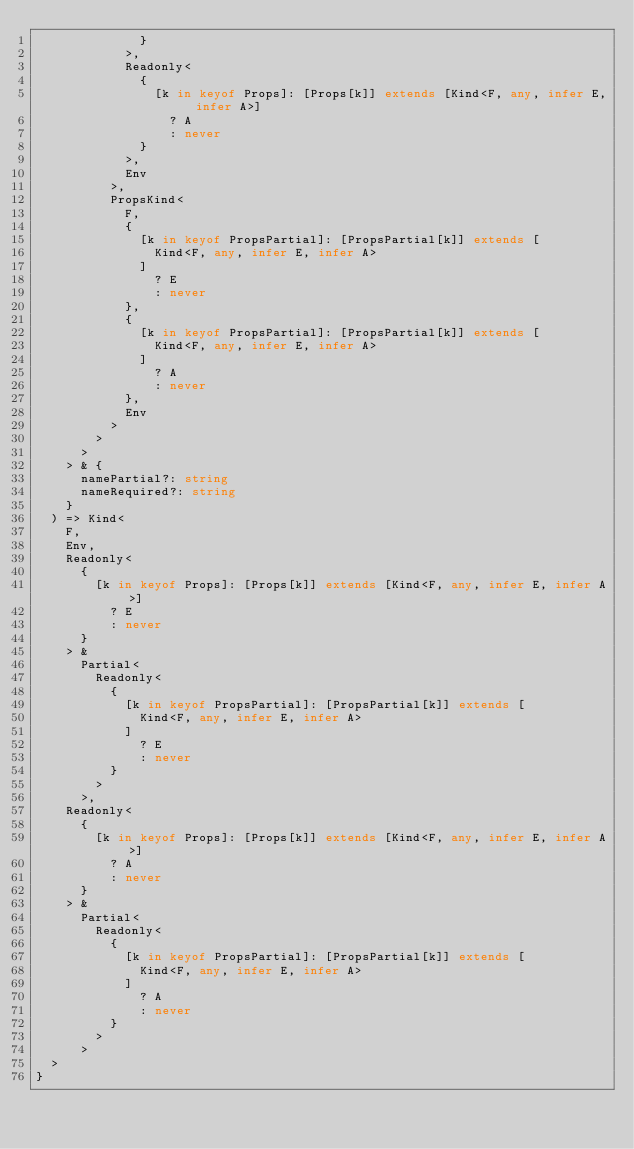Convert code to text. <code><loc_0><loc_0><loc_500><loc_500><_TypeScript_>              }
            >,
            Readonly<
              {
                [k in keyof Props]: [Props[k]] extends [Kind<F, any, infer E, infer A>]
                  ? A
                  : never
              }
            >,
            Env
          >,
          PropsKind<
            F,
            {
              [k in keyof PropsPartial]: [PropsPartial[k]] extends [
                Kind<F, any, infer E, infer A>
              ]
                ? E
                : never
            },
            {
              [k in keyof PropsPartial]: [PropsPartial[k]] extends [
                Kind<F, any, infer E, infer A>
              ]
                ? A
                : never
            },
            Env
          >
        >
      >
    > & {
      namePartial?: string
      nameRequired?: string
    }
  ) => Kind<
    F,
    Env,
    Readonly<
      {
        [k in keyof Props]: [Props[k]] extends [Kind<F, any, infer E, infer A>]
          ? E
          : never
      }
    > &
      Partial<
        Readonly<
          {
            [k in keyof PropsPartial]: [PropsPartial[k]] extends [
              Kind<F, any, infer E, infer A>
            ]
              ? E
              : never
          }
        >
      >,
    Readonly<
      {
        [k in keyof Props]: [Props[k]] extends [Kind<F, any, infer E, infer A>]
          ? A
          : never
      }
    > &
      Partial<
        Readonly<
          {
            [k in keyof PropsPartial]: [PropsPartial[k]] extends [
              Kind<F, any, infer E, infer A>
            ]
              ? A
              : never
          }
        >
      >
  >
}
</code> 